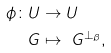Convert formula to latex. <formula><loc_0><loc_0><loc_500><loc_500>\phi \colon U & \rightarrow U \\ \ G & \mapsto \ G ^ { \perp _ { \beta } } ,</formula> 